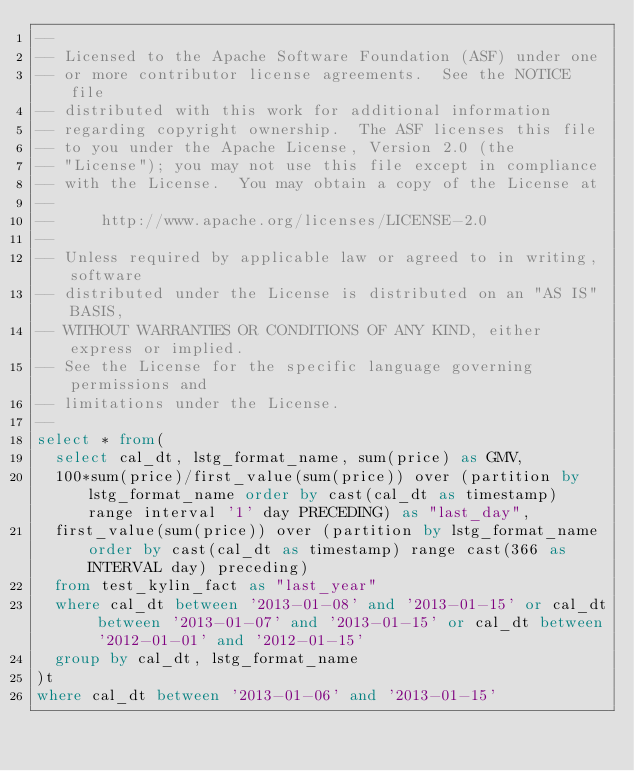<code> <loc_0><loc_0><loc_500><loc_500><_SQL_>--
-- Licensed to the Apache Software Foundation (ASF) under one
-- or more contributor license agreements.  See the NOTICE file
-- distributed with this work for additional information
-- regarding copyright ownership.  The ASF licenses this file
-- to you under the Apache License, Version 2.0 (the
-- "License"); you may not use this file except in compliance
-- with the License.  You may obtain a copy of the License at
--
--     http://www.apache.org/licenses/LICENSE-2.0
--
-- Unless required by applicable law or agreed to in writing, software
-- distributed under the License is distributed on an "AS IS" BASIS,
-- WITHOUT WARRANTIES OR CONDITIONS OF ANY KIND, either express or implied.
-- See the License for the specific language governing permissions and
-- limitations under the License.
--
select * from(
  select cal_dt, lstg_format_name, sum(price) as GMV,
  100*sum(price)/first_value(sum(price)) over (partition by lstg_format_name order by cast(cal_dt as timestamp) range interval '1' day PRECEDING) as "last_day",
  first_value(sum(price)) over (partition by lstg_format_name order by cast(cal_dt as timestamp) range cast(366 as INTERVAL day) preceding)
  from test_kylin_fact as "last_year"
  where cal_dt between '2013-01-08' and '2013-01-15' or cal_dt between '2013-01-07' and '2013-01-15' or cal_dt between '2012-01-01' and '2012-01-15'
  group by cal_dt, lstg_format_name
)t
where cal_dt between '2013-01-06' and '2013-01-15'
</code> 